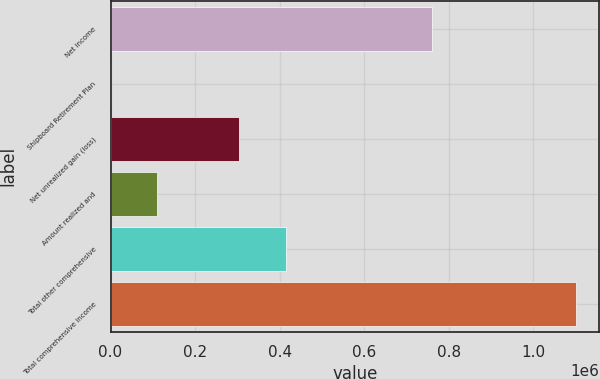Convert chart to OTSL. <chart><loc_0><loc_0><loc_500><loc_500><bar_chart><fcel>Net income<fcel>Shipboard Retirement Plan<fcel>Net unrealized gain (loss)<fcel>Amount realized and<fcel>Total other comprehensive<fcel>Total comprehensive income<nl><fcel>759872<fcel>40<fcel>304684<fcel>110167<fcel>414811<fcel>1.10131e+06<nl></chart> 